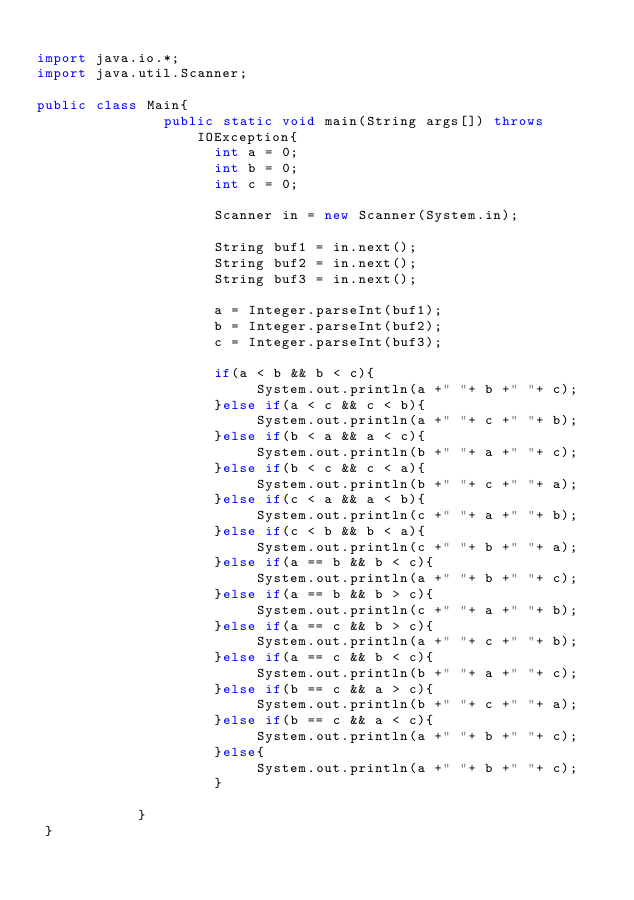Convert code to text. <code><loc_0><loc_0><loc_500><loc_500><_Java_>
import java.io.*;
import java.util.Scanner;

public class Main{
               public static void main(String args[]) throws IOException{
                     int a = 0;
                     int b = 0;
                     int c = 0;
                   
                     Scanner in = new Scanner(System.in);
                     
                     String buf1 = in.next();
                     String buf2 = in.next();
                     String buf3 = in.next();
                     
                     a = Integer.parseInt(buf1);
                     b = Integer.parseInt(buf2);
                     c = Integer.parseInt(buf3);
               
                     if(a < b && b < c){
                          System.out.println(a +" "+ b +" "+ c);
                     }else if(a < c && c < b){
                          System.out.println(a +" "+ c +" "+ b);
                     }else if(b < a && a < c){
                          System.out.println(b +" "+ a +" "+ c);
                     }else if(b < c && c < a){
                          System.out.println(b +" "+ c +" "+ a);
                     }else if(c < a && a < b){
                          System.out.println(c +" "+ a +" "+ b);
                     }else if(c < b && b < a){
                          System.out.println(c +" "+ b +" "+ a);
                     }else if(a == b && b < c){
                          System.out.println(a +" "+ b +" "+ c);
                     }else if(a == b && b > c){
                          System.out.println(c +" "+ a +" "+ b);
                     }else if(a == c && b > c){
                          System.out.println(a +" "+ c +" "+ b);
                     }else if(a == c && b < c){
                          System.out.println(b +" "+ a +" "+ c);
                     }else if(b == c && a > c){
                          System.out.println(b +" "+ c +" "+ a);
                     }else if(b == c && a < c){
                          System.out.println(a +" "+ b +" "+ c);
                     }else{
                          System.out.println(a +" "+ b +" "+ c);
                     }
                     
            }
 }</code> 